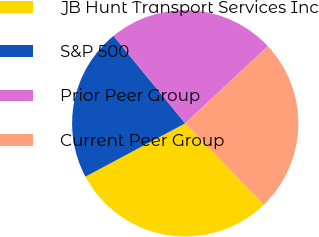Convert chart. <chart><loc_0><loc_0><loc_500><loc_500><pie_chart><fcel>JB Hunt Transport Services Inc<fcel>S&P 500<fcel>Prior Peer Group<fcel>Current Peer Group<nl><fcel>29.42%<fcel>21.88%<fcel>23.97%<fcel>24.73%<nl></chart> 